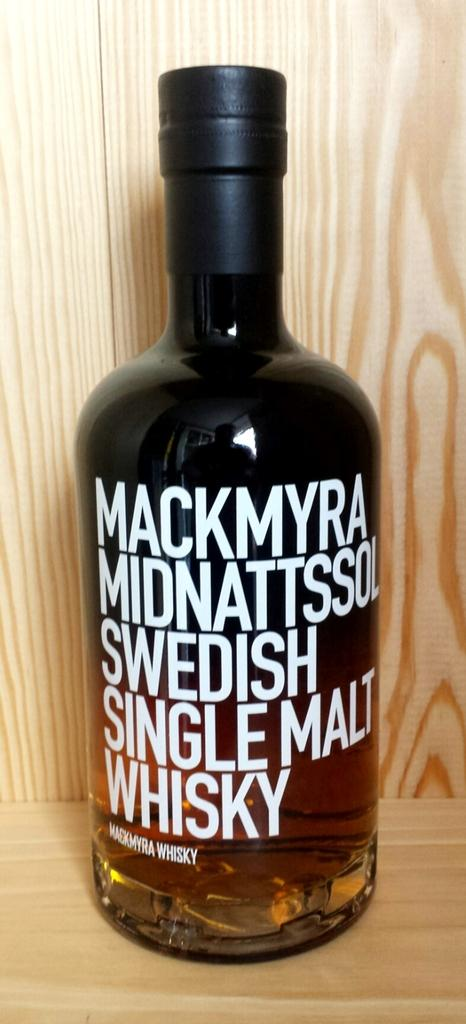<image>
Share a concise interpretation of the image provided. A bottle of Swedish Single Malt Whisky is on a wooden shelf. 